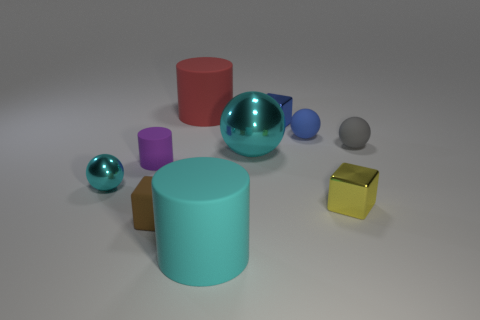Are there any rubber cylinders of the same color as the big metallic thing?
Provide a succinct answer. Yes. Are there an equal number of metallic cubes behind the gray matte object and purple cylinders right of the blue rubber sphere?
Make the answer very short. No. What number of objects are rubber objects to the left of the yellow shiny block or big rubber cylinders that are behind the blue sphere?
Make the answer very short. 5. There is a thing that is both to the right of the big ball and in front of the purple rubber object; what is it made of?
Offer a very short reply. Metal. There is a cyan sphere right of the tiny matte thing on the left side of the block that is in front of the tiny yellow cube; what size is it?
Keep it short and to the point. Large. Are there more small blocks than spheres?
Keep it short and to the point. No. Are the block right of the blue ball and the red cylinder made of the same material?
Provide a succinct answer. No. Is the number of brown matte cubes less than the number of tiny blue rubber cubes?
Provide a short and direct response. No. There is a cyan shiny object that is to the left of the large matte cylinder behind the purple matte thing; is there a large object that is in front of it?
Your answer should be compact. Yes. There is a large matte thing on the left side of the large cyan cylinder; is its shape the same as the large cyan shiny object?
Your answer should be compact. No. 